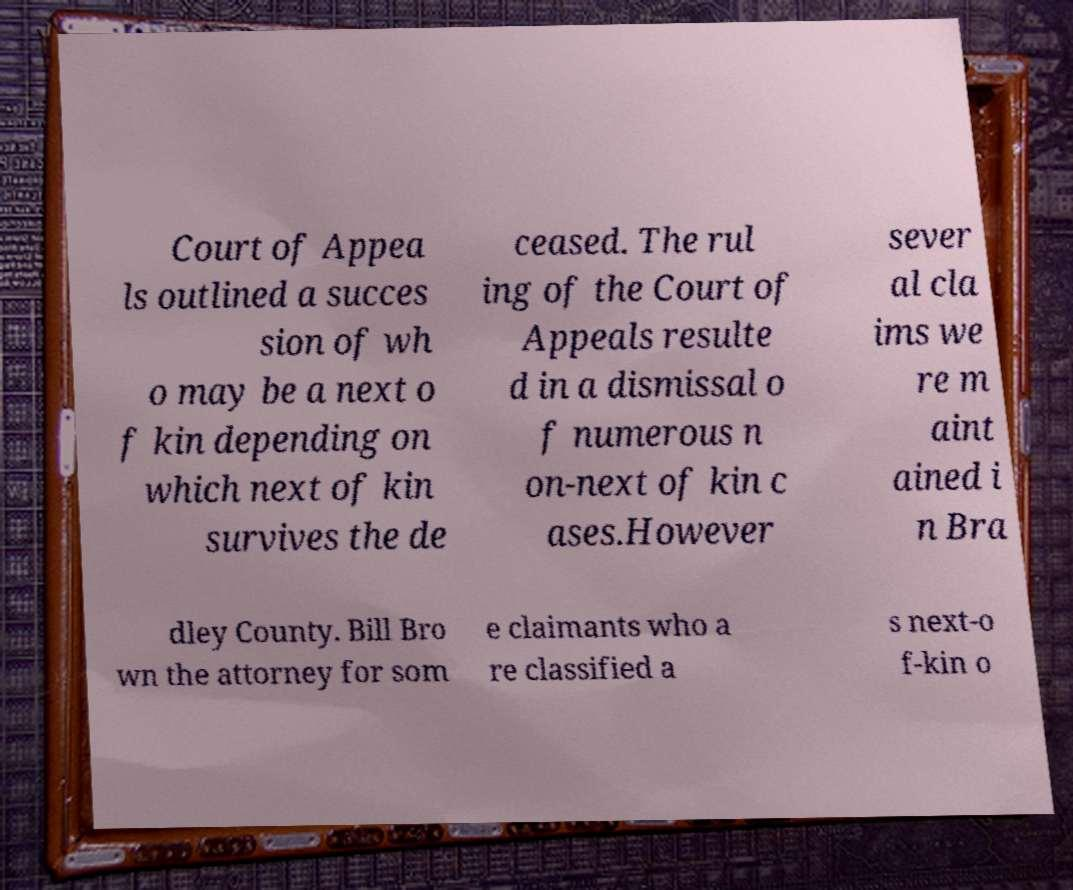For documentation purposes, I need the text within this image transcribed. Could you provide that? Court of Appea ls outlined a succes sion of wh o may be a next o f kin depending on which next of kin survives the de ceased. The rul ing of the Court of Appeals resulte d in a dismissal o f numerous n on-next of kin c ases.However sever al cla ims we re m aint ained i n Bra dley County. Bill Bro wn the attorney for som e claimants who a re classified a s next-o f-kin o 